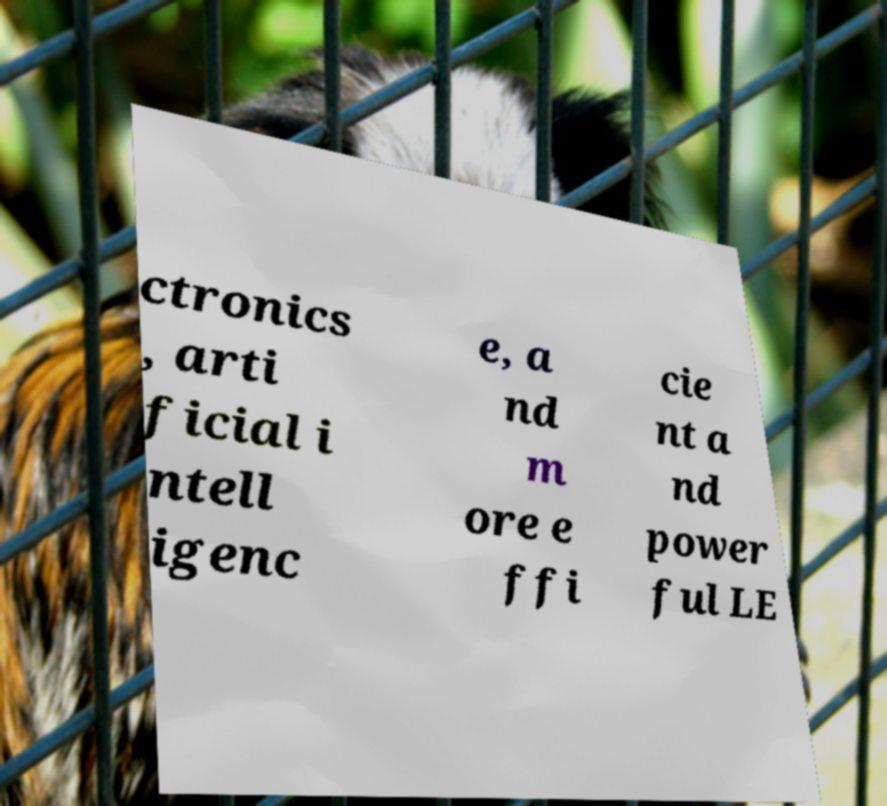For documentation purposes, I need the text within this image transcribed. Could you provide that? ctronics , arti ficial i ntell igenc e, a nd m ore e ffi cie nt a nd power ful LE 